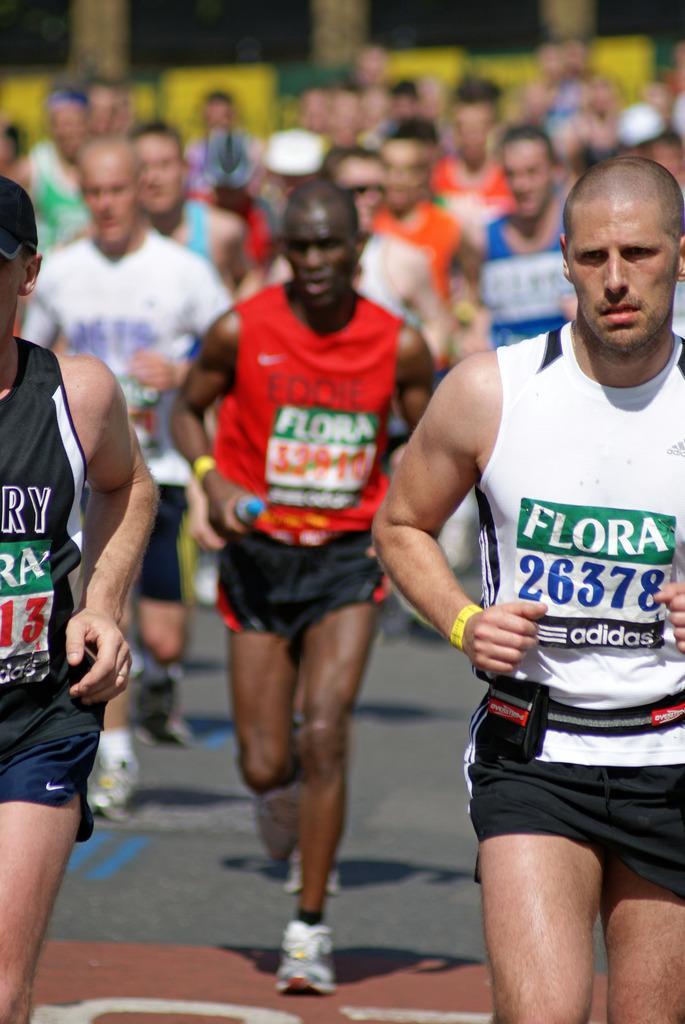<image>
Render a clear and concise summary of the photo. a man running with a flora shirt on 